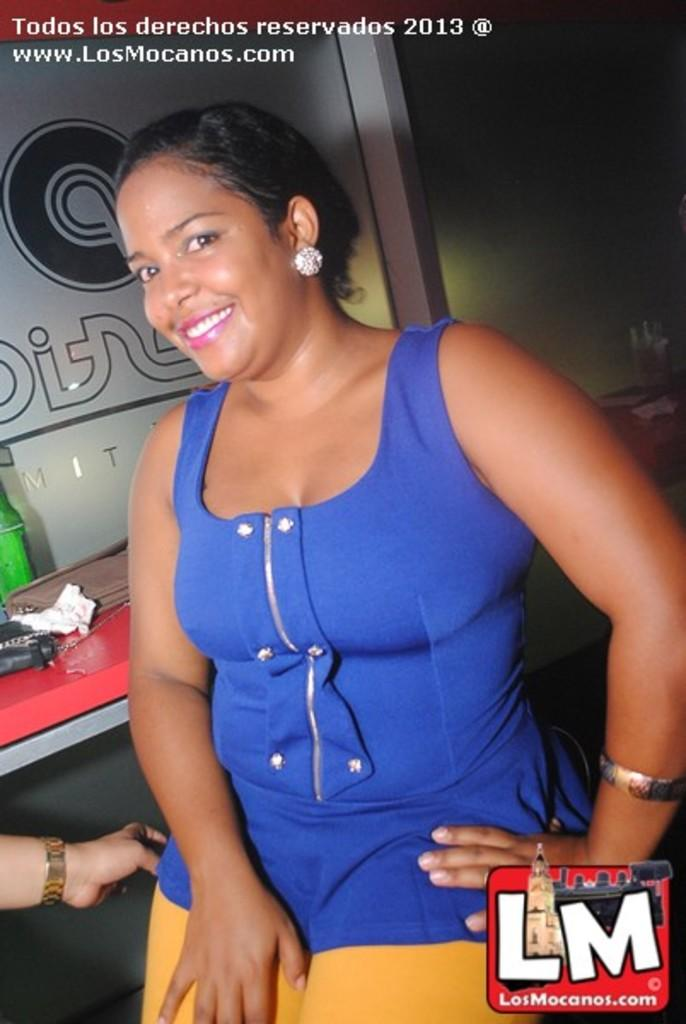<image>
Create a compact narrative representing the image presented. An LM logo can be seen near a woman in a blue tank top. 